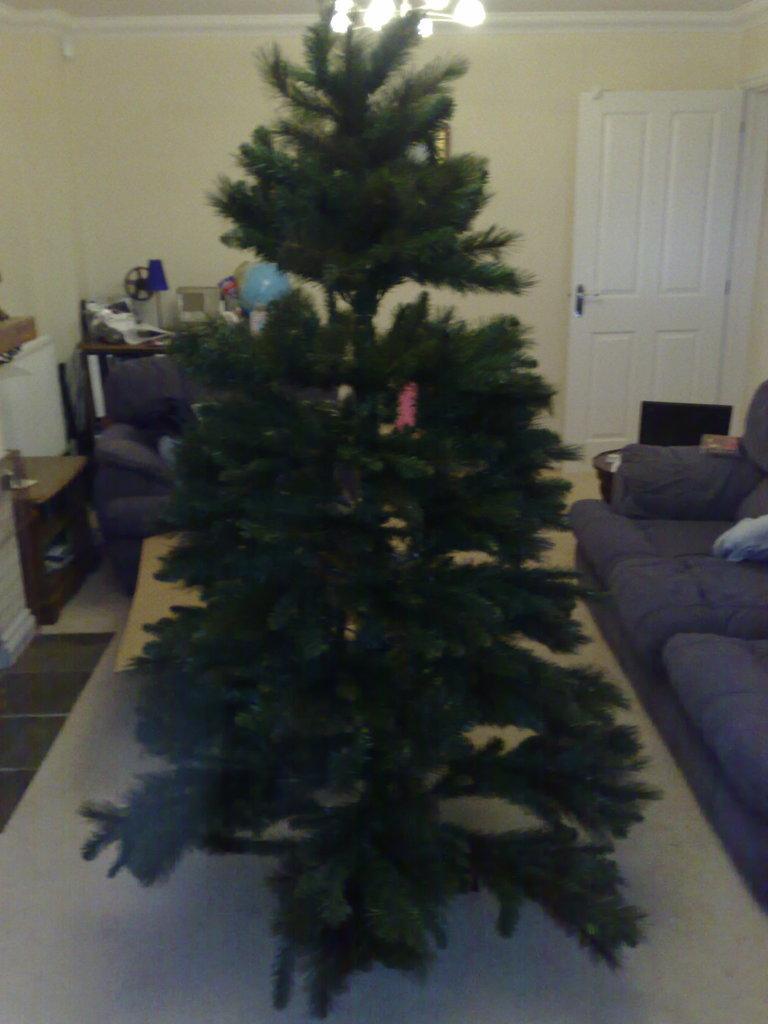How would you summarize this image in a sentence or two? In this picture I can see a tree in front and in the background I can see the sofa set, few things, a door and the wall. On the top of this picture I can see the lights. 